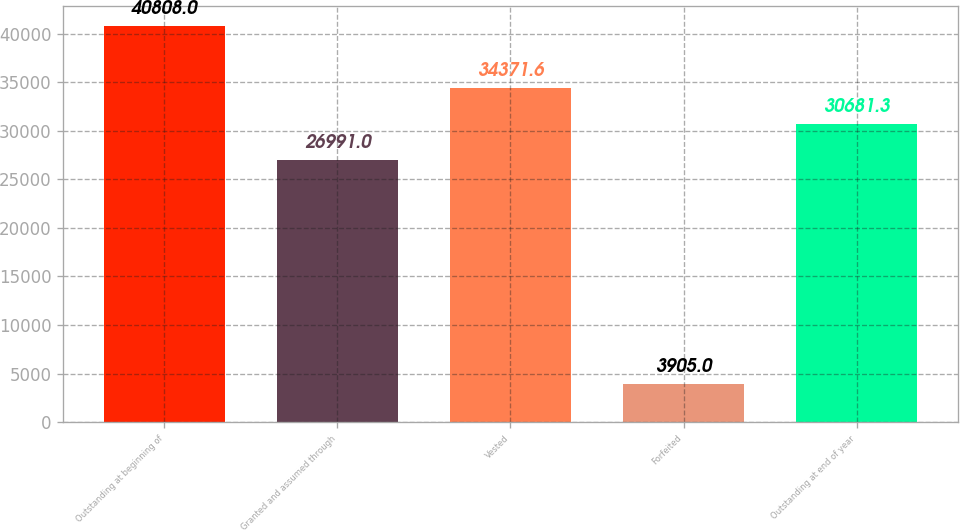<chart> <loc_0><loc_0><loc_500><loc_500><bar_chart><fcel>Outstanding at beginning of<fcel>Granted and assumed through<fcel>Vested<fcel>Forfeited<fcel>Outstanding at end of year<nl><fcel>40808<fcel>26991<fcel>34371.6<fcel>3905<fcel>30681.3<nl></chart> 